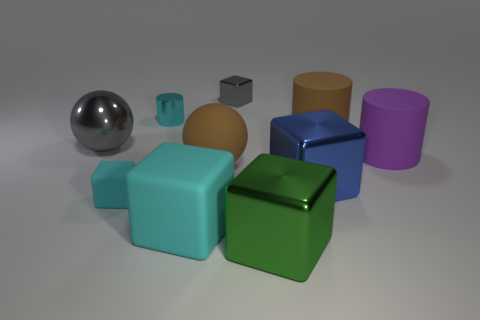There is another cube that is the same color as the big matte cube; what size is it?
Offer a terse response. Small. Are there the same number of big matte balls right of the brown matte cylinder and big cyan shiny blocks?
Offer a terse response. Yes. There is a blue metal thing that is the same size as the rubber ball; what shape is it?
Offer a terse response. Cube. How many other things are the same shape as the big purple matte thing?
Offer a very short reply. 2. There is a brown matte cylinder; is it the same size as the shiny block that is to the left of the big green shiny thing?
Ensure brevity in your answer.  No. How many objects are large things left of the large purple matte cylinder or purple metallic cylinders?
Your answer should be compact. 6. There is a purple matte object that is behind the big blue metallic thing; what is its shape?
Your answer should be compact. Cylinder. Are there the same number of large cylinders on the left side of the large brown matte ball and big brown things in front of the big metallic ball?
Make the answer very short. No. There is a large thing that is both left of the green shiny object and behind the large matte ball; what is its color?
Give a very brief answer. Gray. What is the big cube that is on the left side of the big brown rubber thing left of the big green thing made of?
Offer a terse response. Rubber. 